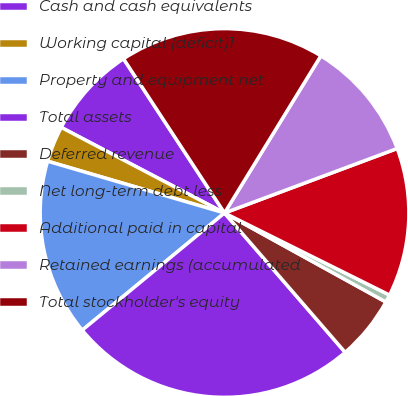<chart> <loc_0><loc_0><loc_500><loc_500><pie_chart><fcel>Cash and cash equivalents<fcel>Working capital (deficit)1<fcel>Property and equipment net<fcel>Total assets<fcel>Deferred revenue<fcel>Net long-term debt less<fcel>Additional paid in capital<fcel>Retained earnings (accumulated<fcel>Total stockholder's equity<nl><fcel>8.09%<fcel>3.15%<fcel>15.5%<fcel>25.39%<fcel>5.62%<fcel>0.68%<fcel>13.03%<fcel>10.56%<fcel>17.98%<nl></chart> 